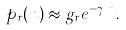<formula> <loc_0><loc_0><loc_500><loc_500>p _ { r } ( n ) \approx g _ { r } e ^ { - \gamma _ { r } n } .</formula> 